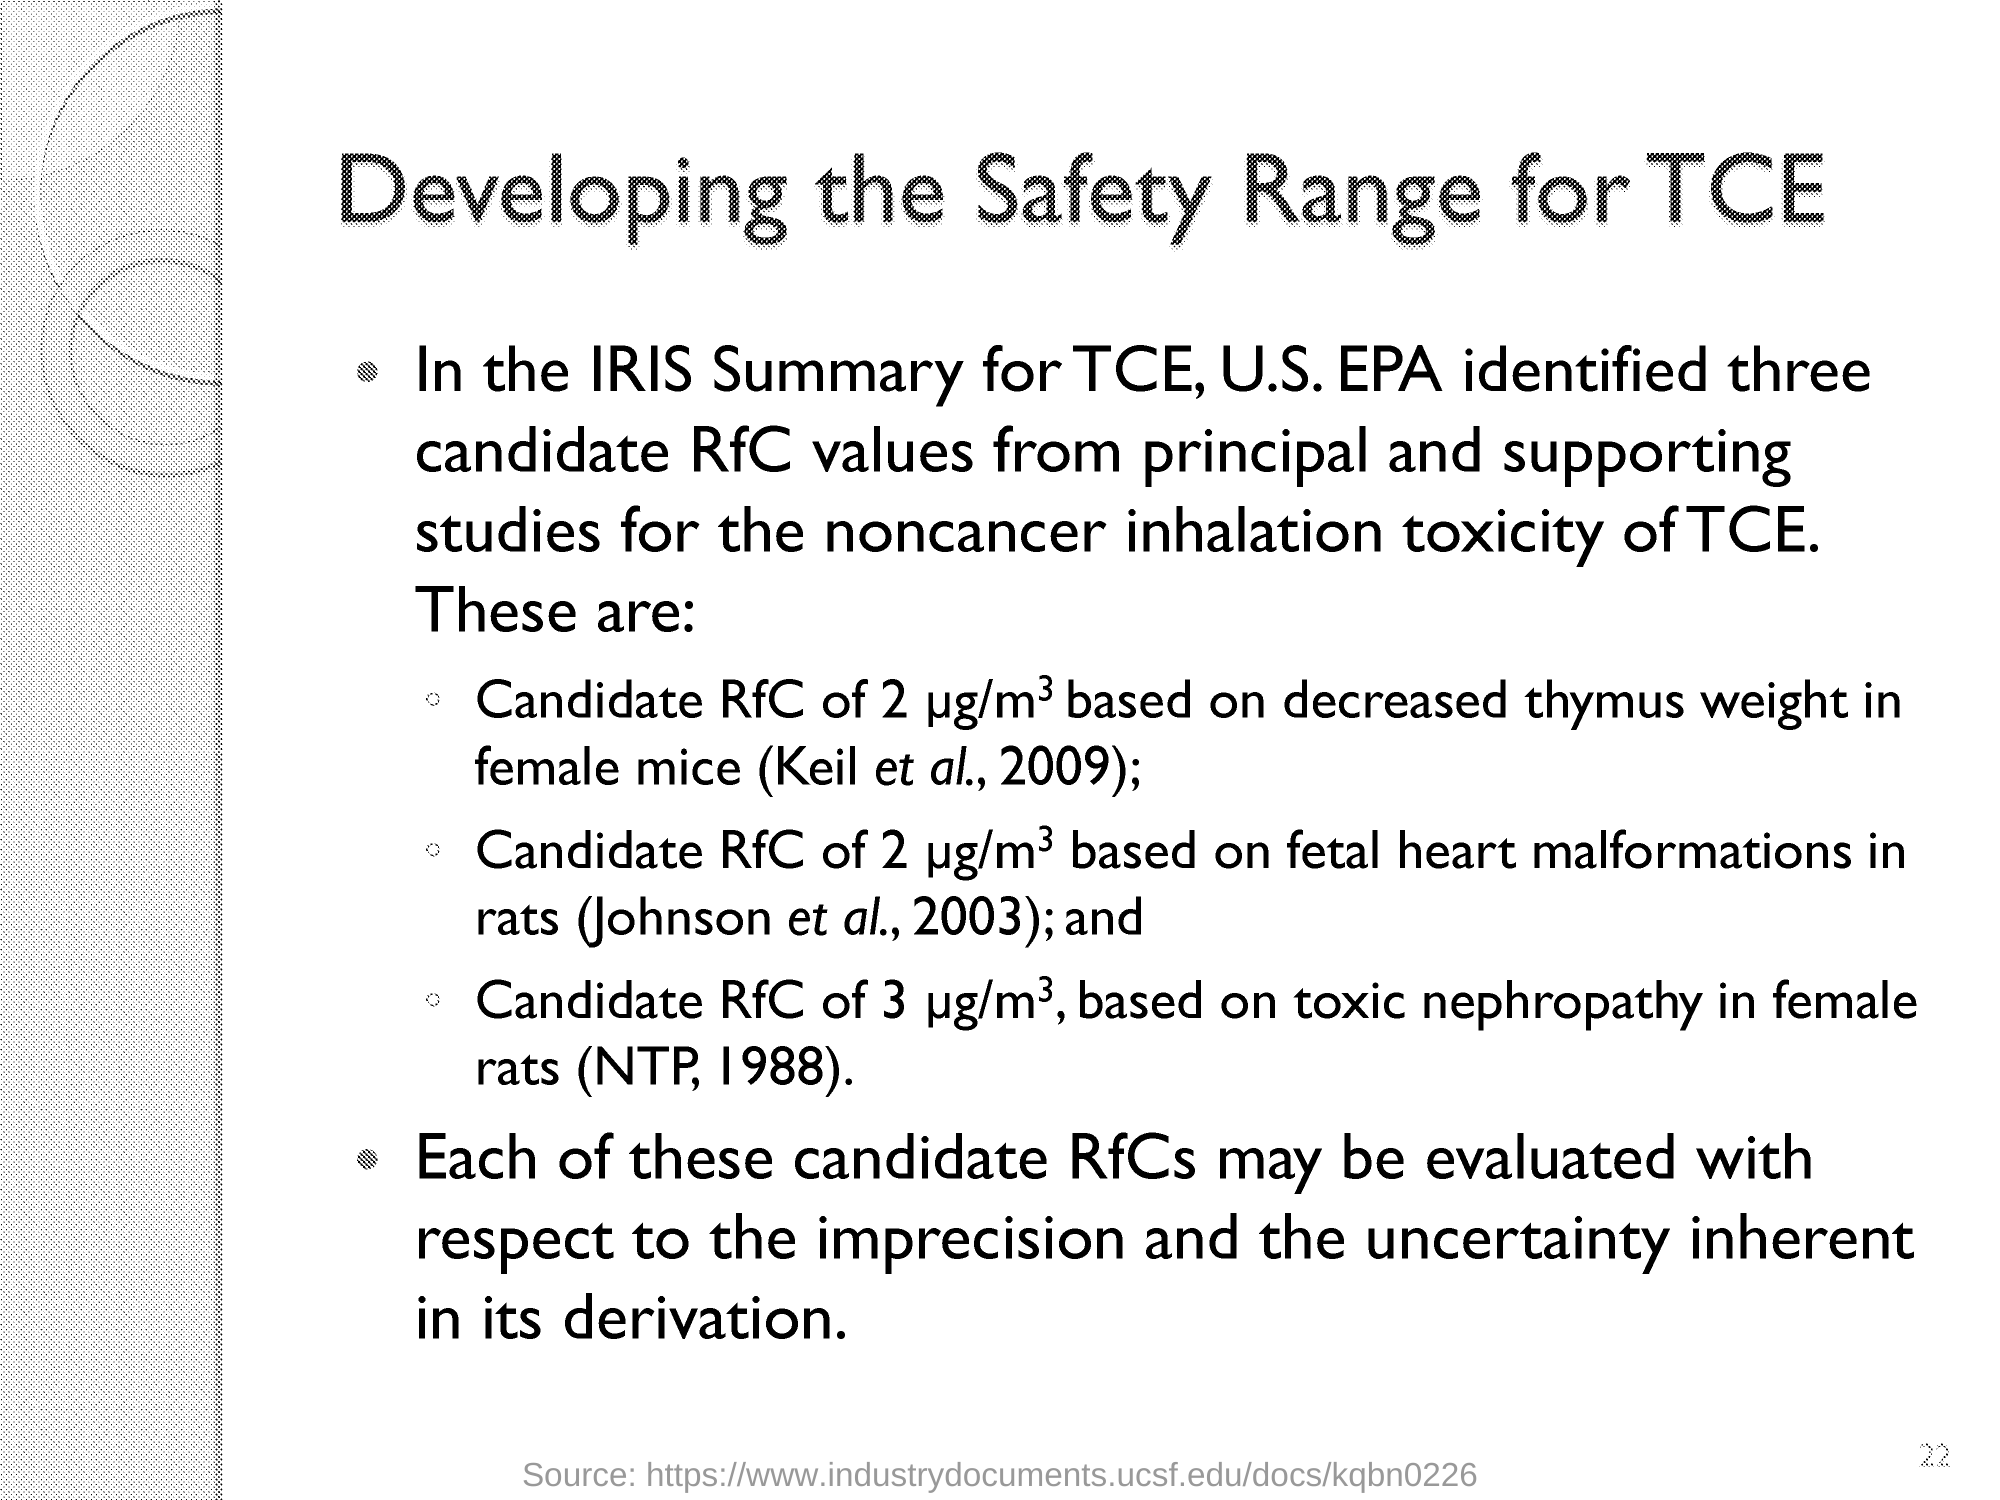Highlight a few significant elements in this photo. The number that is lightly printed on the lower-right side of the document is 22. 